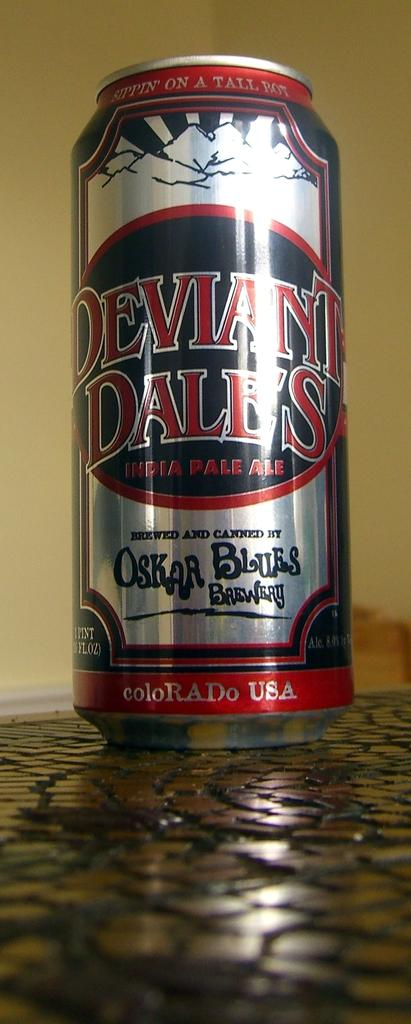<image>
Give a short and clear explanation of the subsequent image. Can of Deviant Dale's made in Colorado USA sitting on a counter. 